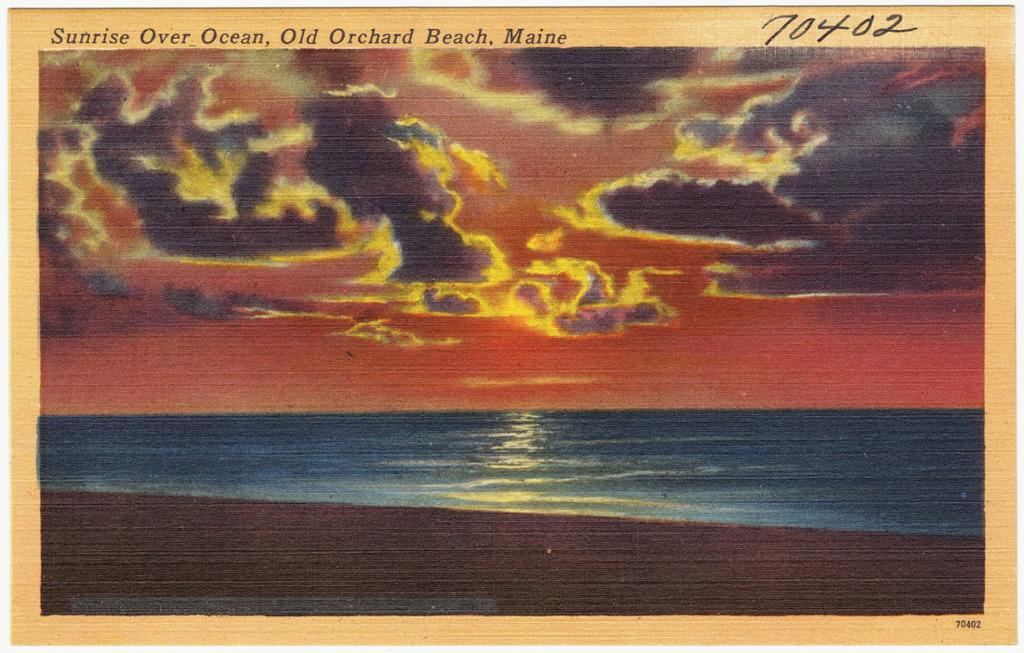<image>
Give a short and clear explanation of the subsequent image. A painting of a sun rise with the title Sunrise over ocean 70402 on the top of it. 